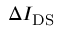Convert formula to latex. <formula><loc_0><loc_0><loc_500><loc_500>\Delta I _ { D S }</formula> 